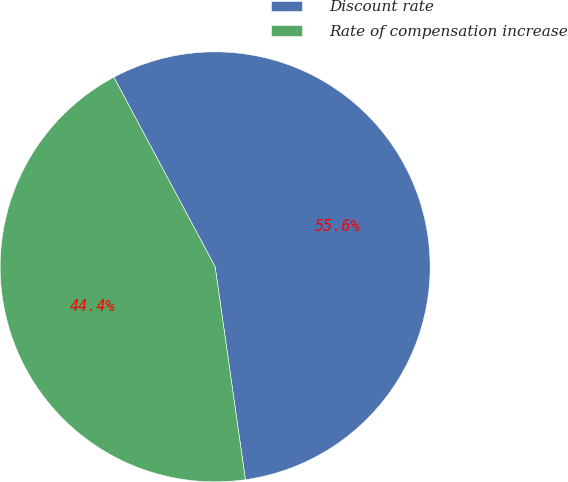Convert chart. <chart><loc_0><loc_0><loc_500><loc_500><pie_chart><fcel>Discount rate<fcel>Rate of compensation increase<nl><fcel>55.56%<fcel>44.44%<nl></chart> 